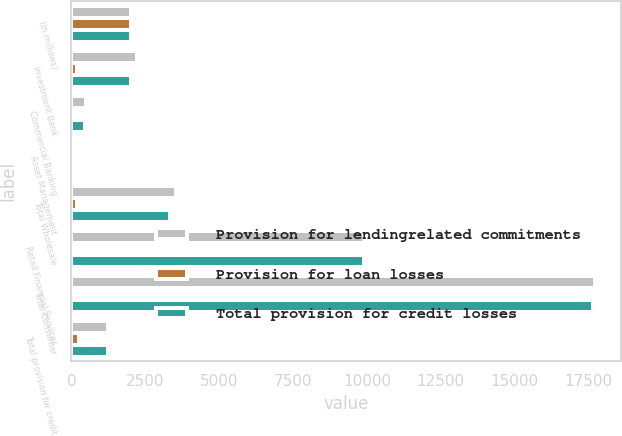Convert chart. <chart><loc_0><loc_0><loc_500><loc_500><stacked_bar_chart><ecel><fcel>(in millions)<fcel>Investment Bank<fcel>Commercial Banking<fcel>Asset Management<fcel>Total Wholesale<fcel>Retail Financial Services<fcel>Total Consumer<fcel>Total provision for credit<nl><fcel>Provision for lendingrelated commitments<fcel>2008<fcel>2216<fcel>505<fcel>87<fcel>3536<fcel>9906<fcel>17701<fcel>1256.5<nl><fcel>Provision for loan losses<fcel>2008<fcel>201<fcel>41<fcel>2<fcel>209<fcel>1<fcel>49<fcel>258<nl><fcel>Total provision for credit losses<fcel>2008<fcel>2015<fcel>464<fcel>85<fcel>3327<fcel>9905<fcel>17652<fcel>1256.5<nl></chart> 